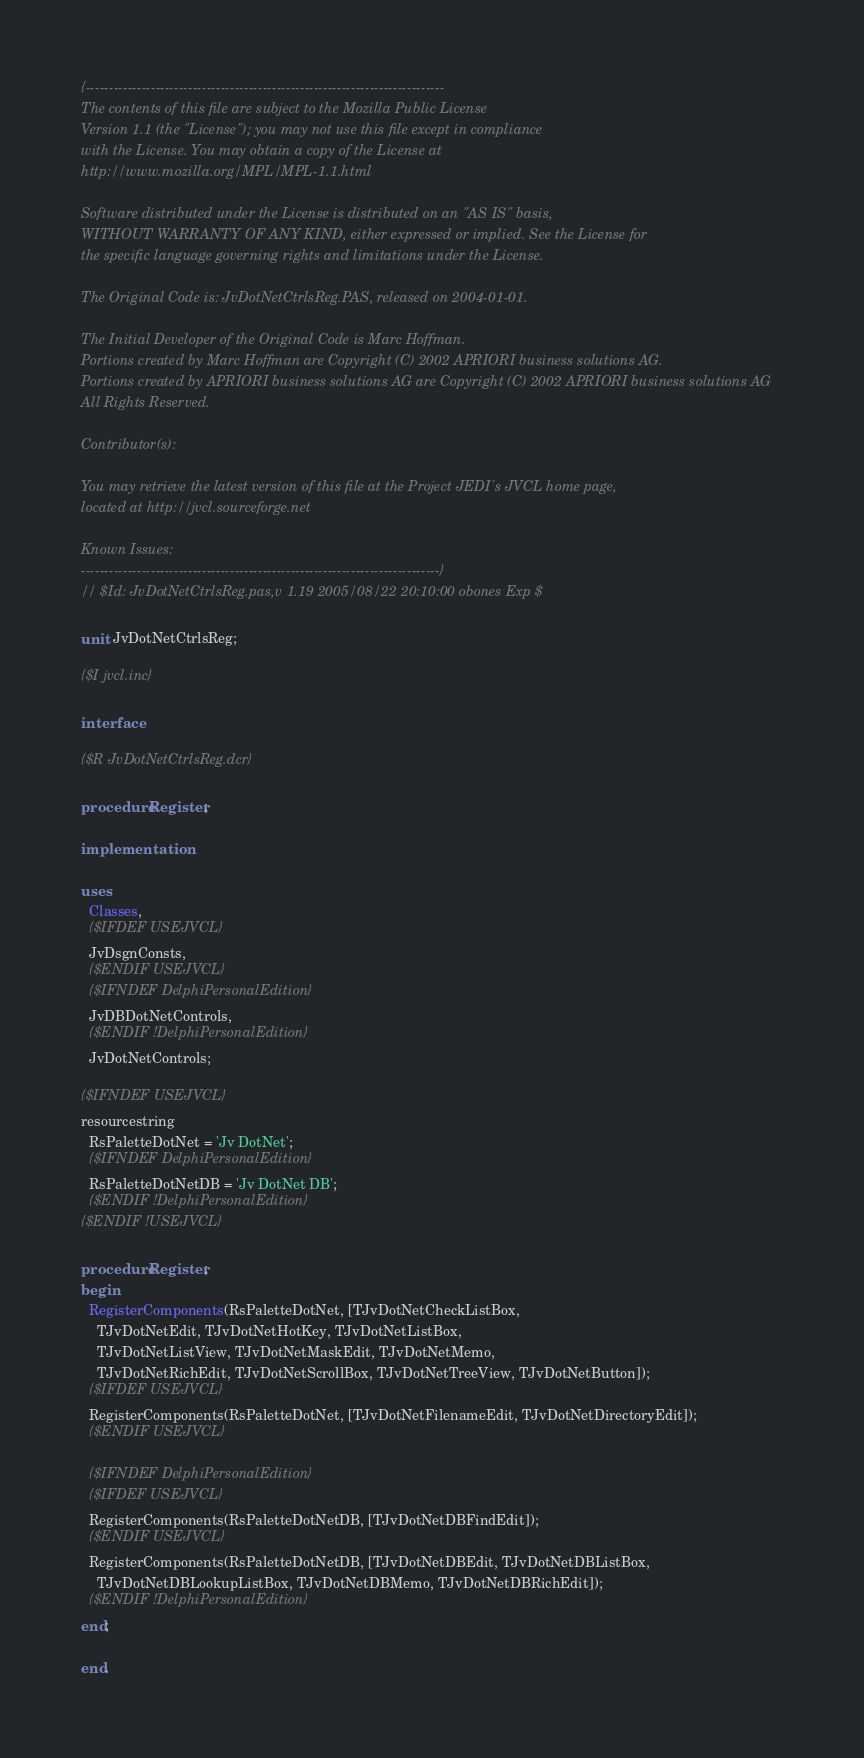<code> <loc_0><loc_0><loc_500><loc_500><_Pascal_>{-----------------------------------------------------------------------------
The contents of this file are subject to the Mozilla Public License
Version 1.1 (the "License"); you may not use this file except in compliance
with the License. You may obtain a copy of the License at
http://www.mozilla.org/MPL/MPL-1.1.html

Software distributed under the License is distributed on an "AS IS" basis,
WITHOUT WARRANTY OF ANY KIND, either expressed or implied. See the License for
the specific language governing rights and limitations under the License.

The Original Code is: JvDotNetCtrlsReg.PAS, released on 2004-01-01.

The Initial Developer of the Original Code is Marc Hoffman.
Portions created by Marc Hoffman are Copyright (C) 2002 APRIORI business solutions AG.
Portions created by APRIORI business solutions AG are Copyright (C) 2002 APRIORI business solutions AG
All Rights Reserved.

Contributor(s):

You may retrieve the latest version of this file at the Project JEDI's JVCL home page,
located at http://jvcl.sourceforge.net

Known Issues:
-----------------------------------------------------------------------------}
// $Id: JvDotNetCtrlsReg.pas,v 1.19 2005/08/22 20:10:00 obones Exp $

unit JvDotNetCtrlsReg;

{$I jvcl.inc}

interface

{$R JvDotNetCtrlsReg.dcr}

procedure Register;

implementation

uses
  Classes,
  {$IFDEF USEJVCL}
  JvDsgnConsts,
  {$ENDIF USEJVCL}
  {$IFNDEF DelphiPersonalEdition}
  JvDBDotNetControls,
  {$ENDIF !DelphiPersonalEdition}
  JvDotNetControls;

{$IFNDEF USEJVCL}
resourcestring
  RsPaletteDotNet = 'Jv DotNet';
  {$IFNDEF DelphiPersonalEdition}
  RsPaletteDotNetDB = 'Jv DotNet DB';
  {$ENDIF !DelphiPersonalEdition}
{$ENDIF !USEJVCL}

procedure Register;
begin
  RegisterComponents(RsPaletteDotNet, [TJvDotNetCheckListBox,
    TJvDotNetEdit, TJvDotNetHotKey, TJvDotNetListBox,
    TJvDotNetListView, TJvDotNetMaskEdit, TJvDotNetMemo,
    TJvDotNetRichEdit, TJvDotNetScrollBox, TJvDotNetTreeView, TJvDotNetButton]);
  {$IFDEF USEJVCL}
  RegisterComponents(RsPaletteDotNet, [TJvDotNetFilenameEdit, TJvDotNetDirectoryEdit]);
  {$ENDIF USEJVCL}

  {$IFNDEF DelphiPersonalEdition}
  {$IFDEF USEJVCL}
  RegisterComponents(RsPaletteDotNetDB, [TJvDotNetDBFindEdit]);
  {$ENDIF USEJVCL}
  RegisterComponents(RsPaletteDotNetDB, [TJvDotNetDBEdit, TJvDotNetDBListBox,
    TJvDotNetDBLookupListBox, TJvDotNetDBMemo, TJvDotNetDBRichEdit]);
  {$ENDIF !DelphiPersonalEdition}
end;

end.
</code> 